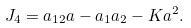<formula> <loc_0><loc_0><loc_500><loc_500>J _ { 4 } = a _ { 1 2 } a - a _ { 1 } a _ { 2 } - K a ^ { 2 } .</formula> 